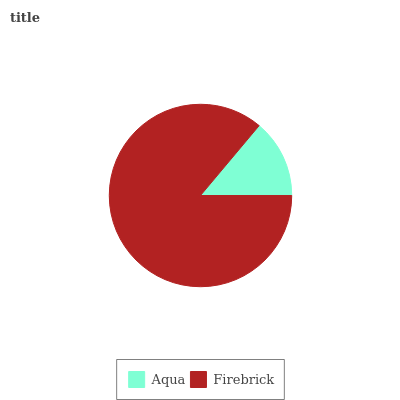Is Aqua the minimum?
Answer yes or no. Yes. Is Firebrick the maximum?
Answer yes or no. Yes. Is Firebrick the minimum?
Answer yes or no. No. Is Firebrick greater than Aqua?
Answer yes or no. Yes. Is Aqua less than Firebrick?
Answer yes or no. Yes. Is Aqua greater than Firebrick?
Answer yes or no. No. Is Firebrick less than Aqua?
Answer yes or no. No. Is Firebrick the high median?
Answer yes or no. Yes. Is Aqua the low median?
Answer yes or no. Yes. Is Aqua the high median?
Answer yes or no. No. Is Firebrick the low median?
Answer yes or no. No. 